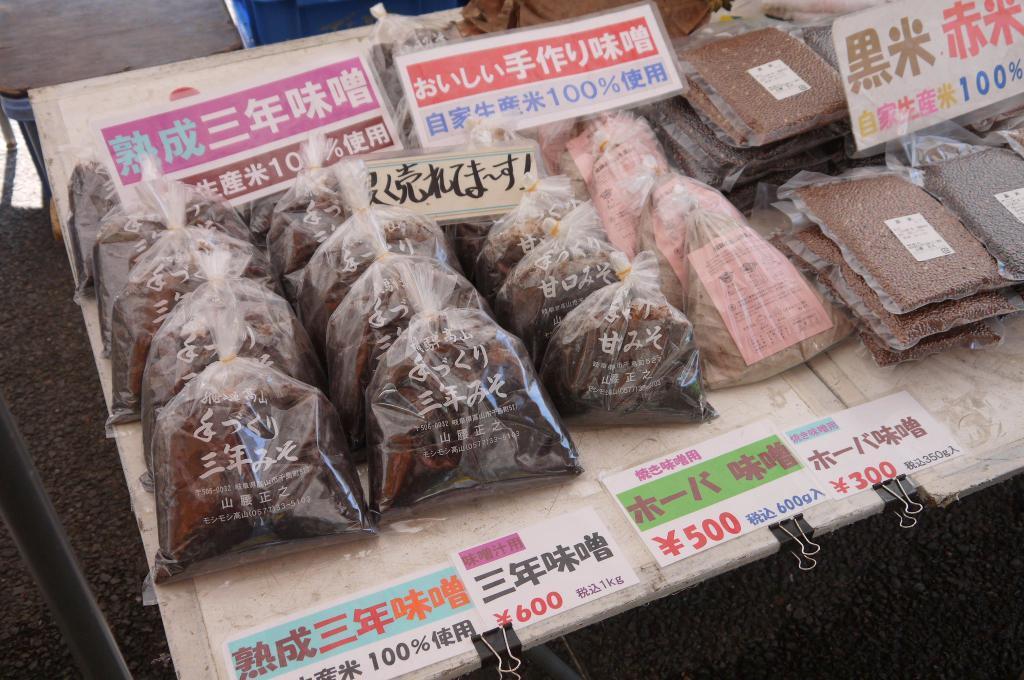How would you summarize this image in a sentence or two? In the foreground of this picture we can see the gravel. In the left corner we can see the metal rod. In the center we can see the tables on the top of which packets containing food items are placed and we can see the text and numbers on the pamphlets which are placed on the top of the table. In the background we can see some objects. 